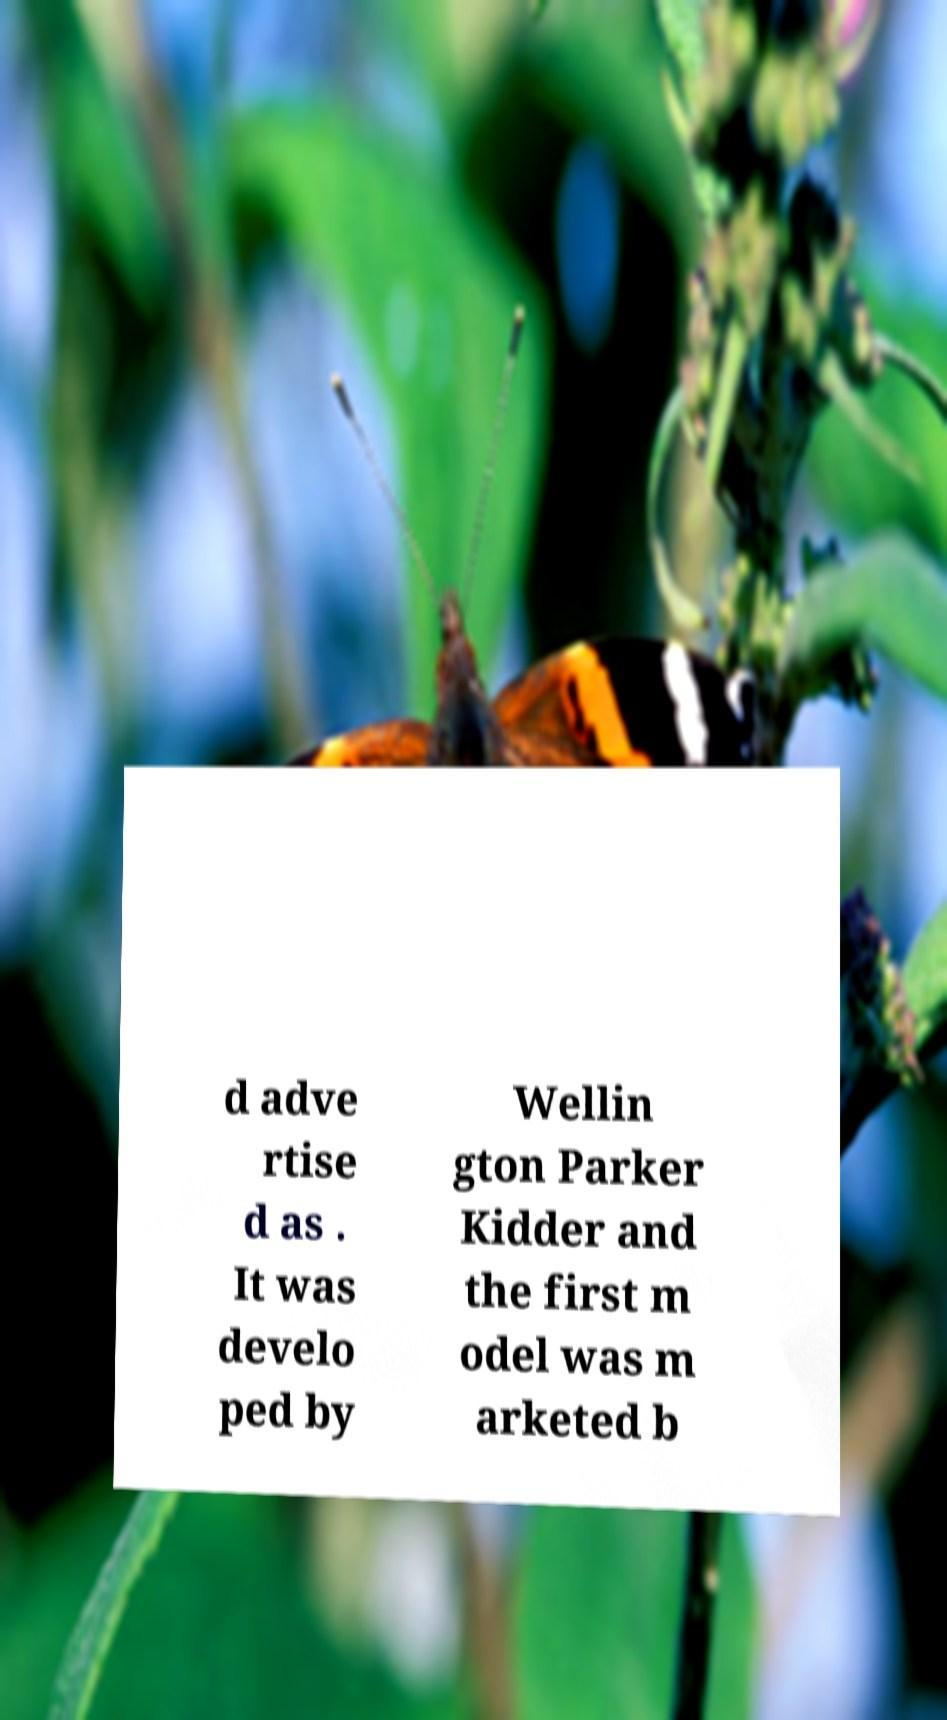Can you read and provide the text displayed in the image?This photo seems to have some interesting text. Can you extract and type it out for me? d adve rtise d as . It was develo ped by Wellin gton Parker Kidder and the first m odel was m arketed b 